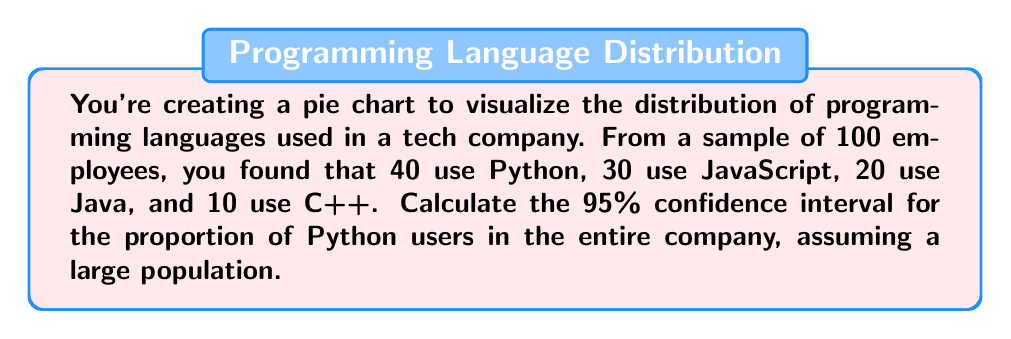Can you answer this question? To calculate the confidence interval for a proportion, we'll use the following steps:

1. Calculate the sample proportion:
   $\hat{p} = \frac{\text{number of successes}}{\text{sample size}} = \frac{40}{100} = 0.4$

2. Determine the z-score for a 95% confidence interval:
   $z_{0.025} = 1.96$ (from the standard normal distribution table)

3. Calculate the standard error:
   $SE = \sqrt{\frac{\hat{p}(1-\hat{p})}{n}} = \sqrt{\frac{0.4(1-0.4)}{100}} = \sqrt{\frac{0.24}{100}} = 0.049$

4. Calculate the margin of error:
   $ME = z_{0.025} \times SE = 1.96 \times 0.049 = 0.096$

5. Determine the confidence interval:
   $CI = \hat{p} \pm ME = 0.4 \pm 0.096$

Therefore, the 95% confidence interval is $(0.4 - 0.096, 0.4 + 0.096) = (0.304, 0.496)$

This means we can be 95% confident that the true proportion of Python users in the entire company falls between 30.4% and 49.6%.
Answer: (0.304, 0.496) 